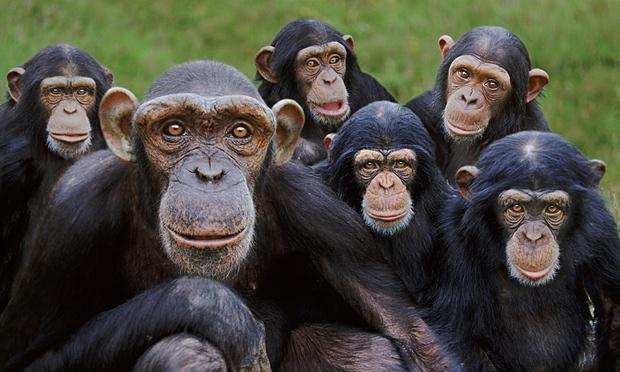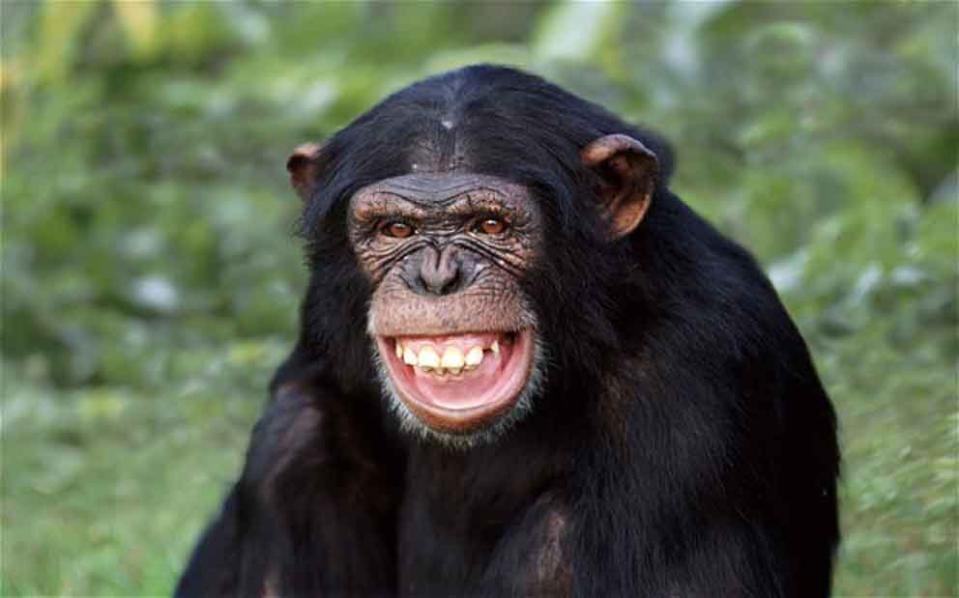The first image is the image on the left, the second image is the image on the right. Considering the images on both sides, is "There is at least one money on the right that is showing its teeth" valid? Answer yes or no. Yes. The first image is the image on the left, the second image is the image on the right. Evaluate the accuracy of this statement regarding the images: "Each image shows two chimps posed side-by-side, but no chimp has a hand visibly grabbing the other chimp or a wide-open mouth.". Is it true? Answer yes or no. No. 